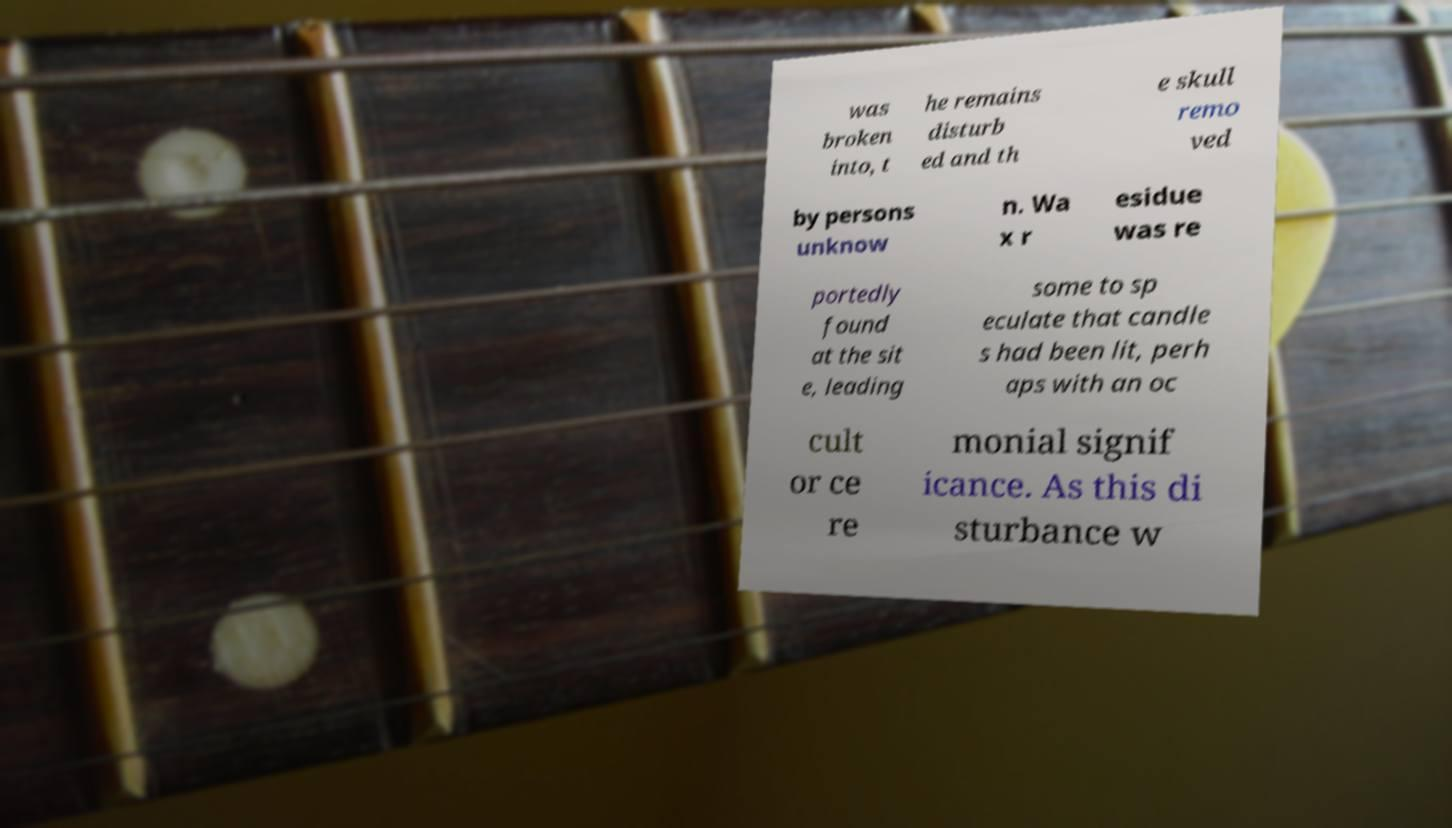Please read and relay the text visible in this image. What does it say? was broken into, t he remains disturb ed and th e skull remo ved by persons unknow n. Wa x r esidue was re portedly found at the sit e, leading some to sp eculate that candle s had been lit, perh aps with an oc cult or ce re monial signif icance. As this di sturbance w 